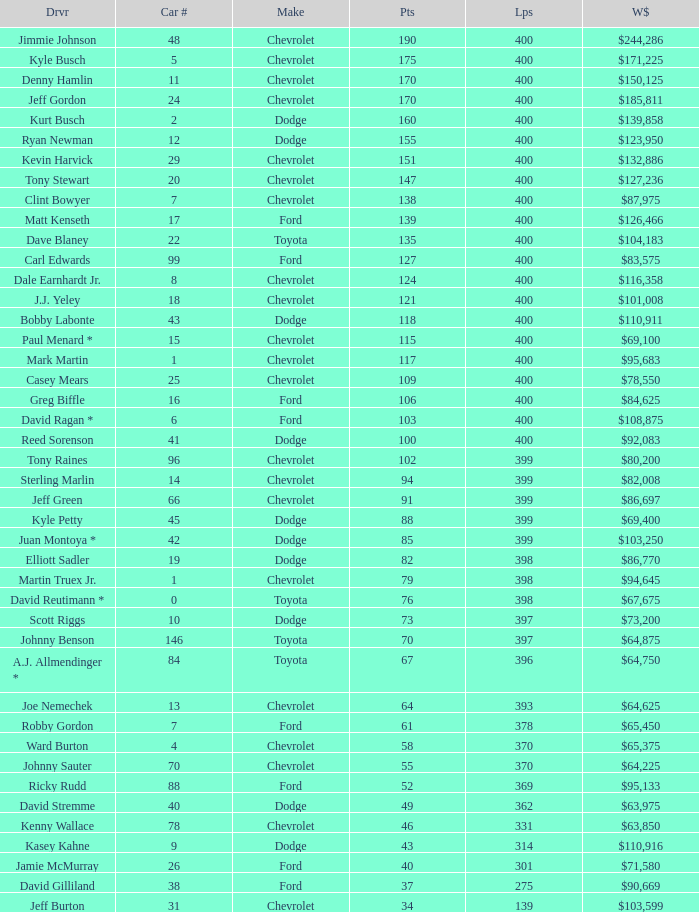For a dodge with over 49 points, which car number has completed fewer than 369 laps? None. 